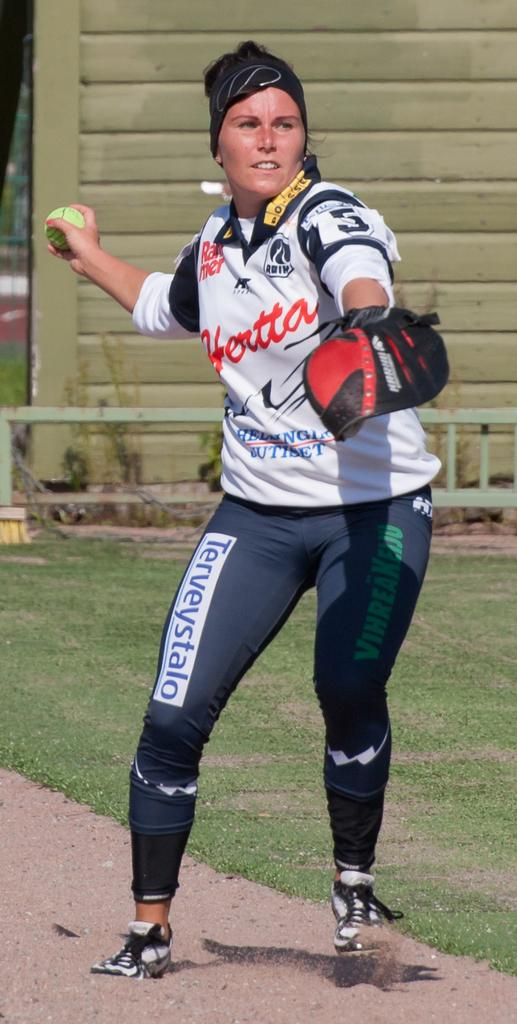<image>
Offer a succinct explanation of the picture presented. Woman wearing a white shirt which says Hertta throwing a ball. 